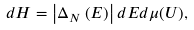Convert formula to latex. <formula><loc_0><loc_0><loc_500><loc_500>d H = \left | \Delta _ { N } \left ( E \right ) \right | d E d \mu ( U ) ,</formula> 